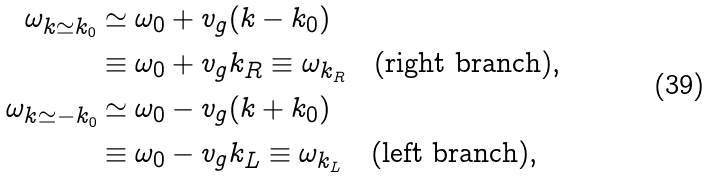Convert formula to latex. <formula><loc_0><loc_0><loc_500><loc_500>\omega _ { k \simeq k _ { 0 } } & \simeq \omega _ { 0 } + v _ { g } ( k - k _ { 0 } ) \\ & \equiv \omega _ { 0 } + v _ { g } k _ { R } \equiv \omega _ { k _ { R } } \quad \text {(right branch)} , \\ \omega _ { k \simeq - k _ { 0 } } & \simeq \omega _ { 0 } - v _ { g } ( k + k _ { 0 } ) \\ & \equiv \omega _ { 0 } - v _ { g } k _ { L } \equiv \omega _ { k _ { L } } \quad \text {(left branch)} ,</formula> 